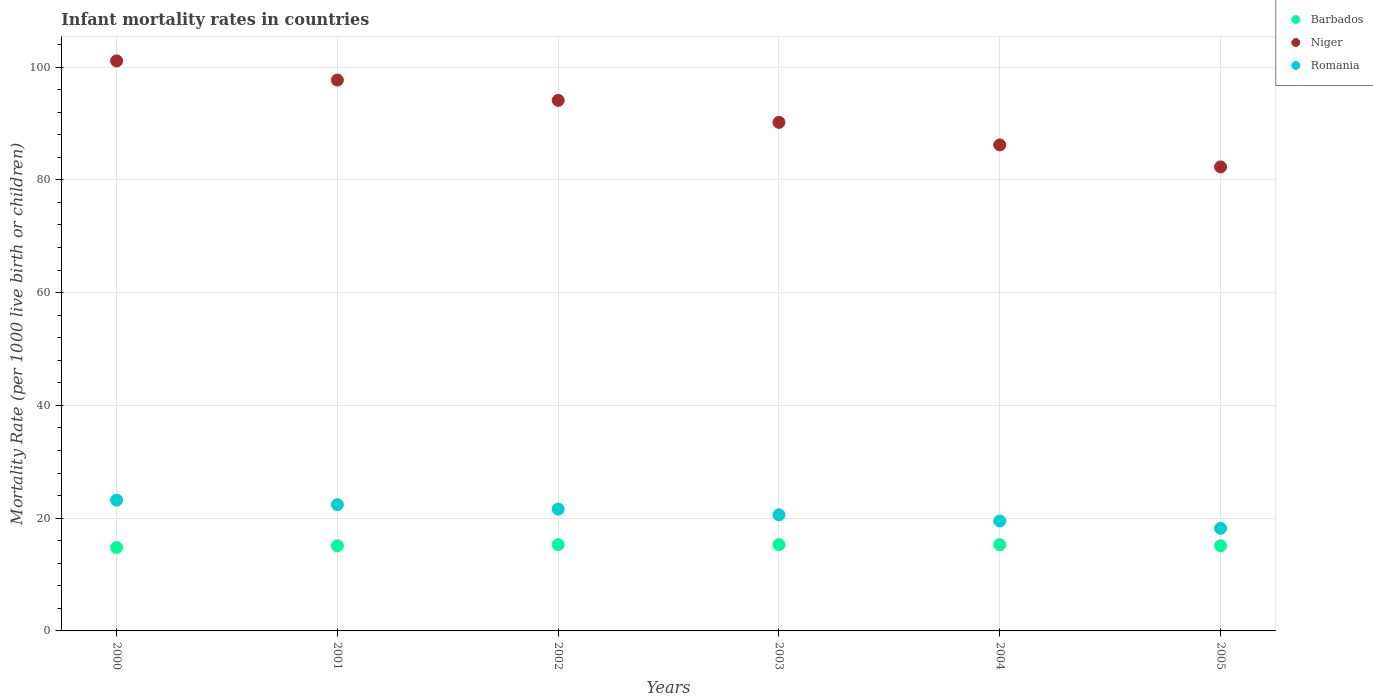What is the infant mortality rate in Niger in 2001?
Ensure brevity in your answer.  97.7. Across all years, what is the maximum infant mortality rate in Romania?
Your answer should be compact. 23.2. Across all years, what is the minimum infant mortality rate in Niger?
Offer a terse response. 82.3. In which year was the infant mortality rate in Niger minimum?
Ensure brevity in your answer.  2005. What is the total infant mortality rate in Niger in the graph?
Keep it short and to the point. 551.6. What is the difference between the infant mortality rate in Romania in 2002 and that in 2004?
Ensure brevity in your answer.  2.1. What is the difference between the infant mortality rate in Romania in 2003 and the infant mortality rate in Barbados in 2000?
Your answer should be compact. 5.8. What is the average infant mortality rate in Niger per year?
Your response must be concise. 91.93. In the year 2005, what is the difference between the infant mortality rate in Barbados and infant mortality rate in Niger?
Your answer should be compact. -67.2. In how many years, is the infant mortality rate in Niger greater than 28?
Your answer should be very brief. 6. What is the ratio of the infant mortality rate in Niger in 2004 to that in 2005?
Give a very brief answer. 1.05. Is the infant mortality rate in Barbados in 2001 less than that in 2002?
Make the answer very short. Yes. What is the difference between the highest and the second highest infant mortality rate in Niger?
Provide a short and direct response. 3.4. Is the infant mortality rate in Niger strictly less than the infant mortality rate in Barbados over the years?
Provide a succinct answer. No. How many years are there in the graph?
Provide a short and direct response. 6. Are the values on the major ticks of Y-axis written in scientific E-notation?
Provide a short and direct response. No. Does the graph contain any zero values?
Give a very brief answer. No. How are the legend labels stacked?
Your response must be concise. Vertical. What is the title of the graph?
Your answer should be very brief. Infant mortality rates in countries. Does "Turks and Caicos Islands" appear as one of the legend labels in the graph?
Your answer should be compact. No. What is the label or title of the Y-axis?
Ensure brevity in your answer.  Mortality Rate (per 1000 live birth or children). What is the Mortality Rate (per 1000 live birth or children) in Barbados in 2000?
Your answer should be very brief. 14.8. What is the Mortality Rate (per 1000 live birth or children) of Niger in 2000?
Your answer should be very brief. 101.1. What is the Mortality Rate (per 1000 live birth or children) of Romania in 2000?
Make the answer very short. 23.2. What is the Mortality Rate (per 1000 live birth or children) of Niger in 2001?
Keep it short and to the point. 97.7. What is the Mortality Rate (per 1000 live birth or children) of Romania in 2001?
Offer a very short reply. 22.4. What is the Mortality Rate (per 1000 live birth or children) of Barbados in 2002?
Give a very brief answer. 15.3. What is the Mortality Rate (per 1000 live birth or children) of Niger in 2002?
Your response must be concise. 94.1. What is the Mortality Rate (per 1000 live birth or children) in Romania in 2002?
Offer a very short reply. 21.6. What is the Mortality Rate (per 1000 live birth or children) of Niger in 2003?
Your answer should be very brief. 90.2. What is the Mortality Rate (per 1000 live birth or children) of Romania in 2003?
Your response must be concise. 20.6. What is the Mortality Rate (per 1000 live birth or children) in Niger in 2004?
Your answer should be very brief. 86.2. What is the Mortality Rate (per 1000 live birth or children) in Romania in 2004?
Offer a terse response. 19.5. What is the Mortality Rate (per 1000 live birth or children) in Barbados in 2005?
Ensure brevity in your answer.  15.1. What is the Mortality Rate (per 1000 live birth or children) in Niger in 2005?
Provide a short and direct response. 82.3. Across all years, what is the maximum Mortality Rate (per 1000 live birth or children) in Barbados?
Provide a short and direct response. 15.3. Across all years, what is the maximum Mortality Rate (per 1000 live birth or children) of Niger?
Your answer should be compact. 101.1. Across all years, what is the maximum Mortality Rate (per 1000 live birth or children) of Romania?
Keep it short and to the point. 23.2. Across all years, what is the minimum Mortality Rate (per 1000 live birth or children) in Barbados?
Your answer should be compact. 14.8. Across all years, what is the minimum Mortality Rate (per 1000 live birth or children) of Niger?
Your answer should be compact. 82.3. Across all years, what is the minimum Mortality Rate (per 1000 live birth or children) in Romania?
Make the answer very short. 18.2. What is the total Mortality Rate (per 1000 live birth or children) in Barbados in the graph?
Your answer should be very brief. 90.9. What is the total Mortality Rate (per 1000 live birth or children) of Niger in the graph?
Your answer should be very brief. 551.6. What is the total Mortality Rate (per 1000 live birth or children) in Romania in the graph?
Provide a succinct answer. 125.5. What is the difference between the Mortality Rate (per 1000 live birth or children) of Barbados in 2000 and that in 2001?
Ensure brevity in your answer.  -0.3. What is the difference between the Mortality Rate (per 1000 live birth or children) in Niger in 2000 and that in 2001?
Your response must be concise. 3.4. What is the difference between the Mortality Rate (per 1000 live birth or children) in Barbados in 2000 and that in 2004?
Provide a short and direct response. -0.5. What is the difference between the Mortality Rate (per 1000 live birth or children) in Niger in 2000 and that in 2004?
Provide a short and direct response. 14.9. What is the difference between the Mortality Rate (per 1000 live birth or children) of Romania in 2000 and that in 2004?
Keep it short and to the point. 3.7. What is the difference between the Mortality Rate (per 1000 live birth or children) in Barbados in 2000 and that in 2005?
Provide a short and direct response. -0.3. What is the difference between the Mortality Rate (per 1000 live birth or children) of Romania in 2000 and that in 2005?
Provide a succinct answer. 5. What is the difference between the Mortality Rate (per 1000 live birth or children) in Barbados in 2001 and that in 2002?
Provide a succinct answer. -0.2. What is the difference between the Mortality Rate (per 1000 live birth or children) of Niger in 2001 and that in 2002?
Ensure brevity in your answer.  3.6. What is the difference between the Mortality Rate (per 1000 live birth or children) in Romania in 2001 and that in 2002?
Make the answer very short. 0.8. What is the difference between the Mortality Rate (per 1000 live birth or children) in Romania in 2001 and that in 2003?
Provide a short and direct response. 1.8. What is the difference between the Mortality Rate (per 1000 live birth or children) in Romania in 2001 and that in 2004?
Offer a terse response. 2.9. What is the difference between the Mortality Rate (per 1000 live birth or children) of Barbados in 2001 and that in 2005?
Offer a terse response. 0. What is the difference between the Mortality Rate (per 1000 live birth or children) of Niger in 2002 and that in 2003?
Provide a succinct answer. 3.9. What is the difference between the Mortality Rate (per 1000 live birth or children) of Barbados in 2002 and that in 2004?
Your answer should be very brief. 0. What is the difference between the Mortality Rate (per 1000 live birth or children) of Romania in 2002 and that in 2004?
Your answer should be compact. 2.1. What is the difference between the Mortality Rate (per 1000 live birth or children) of Barbados in 2002 and that in 2005?
Your answer should be very brief. 0.2. What is the difference between the Mortality Rate (per 1000 live birth or children) of Niger in 2002 and that in 2005?
Keep it short and to the point. 11.8. What is the difference between the Mortality Rate (per 1000 live birth or children) of Romania in 2002 and that in 2005?
Provide a succinct answer. 3.4. What is the difference between the Mortality Rate (per 1000 live birth or children) in Barbados in 2003 and that in 2004?
Provide a succinct answer. 0. What is the difference between the Mortality Rate (per 1000 live birth or children) of Niger in 2003 and that in 2004?
Give a very brief answer. 4. What is the difference between the Mortality Rate (per 1000 live birth or children) of Romania in 2003 and that in 2004?
Give a very brief answer. 1.1. What is the difference between the Mortality Rate (per 1000 live birth or children) in Niger in 2003 and that in 2005?
Provide a short and direct response. 7.9. What is the difference between the Mortality Rate (per 1000 live birth or children) of Barbados in 2004 and that in 2005?
Give a very brief answer. 0.2. What is the difference between the Mortality Rate (per 1000 live birth or children) in Niger in 2004 and that in 2005?
Your answer should be compact. 3.9. What is the difference between the Mortality Rate (per 1000 live birth or children) of Barbados in 2000 and the Mortality Rate (per 1000 live birth or children) of Niger in 2001?
Offer a very short reply. -82.9. What is the difference between the Mortality Rate (per 1000 live birth or children) of Niger in 2000 and the Mortality Rate (per 1000 live birth or children) of Romania in 2001?
Your answer should be very brief. 78.7. What is the difference between the Mortality Rate (per 1000 live birth or children) of Barbados in 2000 and the Mortality Rate (per 1000 live birth or children) of Niger in 2002?
Provide a succinct answer. -79.3. What is the difference between the Mortality Rate (per 1000 live birth or children) in Barbados in 2000 and the Mortality Rate (per 1000 live birth or children) in Romania in 2002?
Keep it short and to the point. -6.8. What is the difference between the Mortality Rate (per 1000 live birth or children) of Niger in 2000 and the Mortality Rate (per 1000 live birth or children) of Romania in 2002?
Offer a terse response. 79.5. What is the difference between the Mortality Rate (per 1000 live birth or children) in Barbados in 2000 and the Mortality Rate (per 1000 live birth or children) in Niger in 2003?
Ensure brevity in your answer.  -75.4. What is the difference between the Mortality Rate (per 1000 live birth or children) of Barbados in 2000 and the Mortality Rate (per 1000 live birth or children) of Romania in 2003?
Give a very brief answer. -5.8. What is the difference between the Mortality Rate (per 1000 live birth or children) of Niger in 2000 and the Mortality Rate (per 1000 live birth or children) of Romania in 2003?
Offer a terse response. 80.5. What is the difference between the Mortality Rate (per 1000 live birth or children) in Barbados in 2000 and the Mortality Rate (per 1000 live birth or children) in Niger in 2004?
Keep it short and to the point. -71.4. What is the difference between the Mortality Rate (per 1000 live birth or children) in Barbados in 2000 and the Mortality Rate (per 1000 live birth or children) in Romania in 2004?
Ensure brevity in your answer.  -4.7. What is the difference between the Mortality Rate (per 1000 live birth or children) of Niger in 2000 and the Mortality Rate (per 1000 live birth or children) of Romania in 2004?
Provide a short and direct response. 81.6. What is the difference between the Mortality Rate (per 1000 live birth or children) of Barbados in 2000 and the Mortality Rate (per 1000 live birth or children) of Niger in 2005?
Give a very brief answer. -67.5. What is the difference between the Mortality Rate (per 1000 live birth or children) of Barbados in 2000 and the Mortality Rate (per 1000 live birth or children) of Romania in 2005?
Offer a terse response. -3.4. What is the difference between the Mortality Rate (per 1000 live birth or children) in Niger in 2000 and the Mortality Rate (per 1000 live birth or children) in Romania in 2005?
Make the answer very short. 82.9. What is the difference between the Mortality Rate (per 1000 live birth or children) of Barbados in 2001 and the Mortality Rate (per 1000 live birth or children) of Niger in 2002?
Make the answer very short. -79. What is the difference between the Mortality Rate (per 1000 live birth or children) of Niger in 2001 and the Mortality Rate (per 1000 live birth or children) of Romania in 2002?
Your answer should be very brief. 76.1. What is the difference between the Mortality Rate (per 1000 live birth or children) in Barbados in 2001 and the Mortality Rate (per 1000 live birth or children) in Niger in 2003?
Your response must be concise. -75.1. What is the difference between the Mortality Rate (per 1000 live birth or children) in Niger in 2001 and the Mortality Rate (per 1000 live birth or children) in Romania in 2003?
Offer a terse response. 77.1. What is the difference between the Mortality Rate (per 1000 live birth or children) in Barbados in 2001 and the Mortality Rate (per 1000 live birth or children) in Niger in 2004?
Keep it short and to the point. -71.1. What is the difference between the Mortality Rate (per 1000 live birth or children) in Barbados in 2001 and the Mortality Rate (per 1000 live birth or children) in Romania in 2004?
Offer a very short reply. -4.4. What is the difference between the Mortality Rate (per 1000 live birth or children) in Niger in 2001 and the Mortality Rate (per 1000 live birth or children) in Romania in 2004?
Offer a very short reply. 78.2. What is the difference between the Mortality Rate (per 1000 live birth or children) in Barbados in 2001 and the Mortality Rate (per 1000 live birth or children) in Niger in 2005?
Make the answer very short. -67.2. What is the difference between the Mortality Rate (per 1000 live birth or children) of Barbados in 2001 and the Mortality Rate (per 1000 live birth or children) of Romania in 2005?
Give a very brief answer. -3.1. What is the difference between the Mortality Rate (per 1000 live birth or children) in Niger in 2001 and the Mortality Rate (per 1000 live birth or children) in Romania in 2005?
Keep it short and to the point. 79.5. What is the difference between the Mortality Rate (per 1000 live birth or children) in Barbados in 2002 and the Mortality Rate (per 1000 live birth or children) in Niger in 2003?
Give a very brief answer. -74.9. What is the difference between the Mortality Rate (per 1000 live birth or children) of Niger in 2002 and the Mortality Rate (per 1000 live birth or children) of Romania in 2003?
Provide a succinct answer. 73.5. What is the difference between the Mortality Rate (per 1000 live birth or children) in Barbados in 2002 and the Mortality Rate (per 1000 live birth or children) in Niger in 2004?
Make the answer very short. -70.9. What is the difference between the Mortality Rate (per 1000 live birth or children) of Niger in 2002 and the Mortality Rate (per 1000 live birth or children) of Romania in 2004?
Your answer should be compact. 74.6. What is the difference between the Mortality Rate (per 1000 live birth or children) in Barbados in 2002 and the Mortality Rate (per 1000 live birth or children) in Niger in 2005?
Keep it short and to the point. -67. What is the difference between the Mortality Rate (per 1000 live birth or children) of Niger in 2002 and the Mortality Rate (per 1000 live birth or children) of Romania in 2005?
Your response must be concise. 75.9. What is the difference between the Mortality Rate (per 1000 live birth or children) of Barbados in 2003 and the Mortality Rate (per 1000 live birth or children) of Niger in 2004?
Give a very brief answer. -70.9. What is the difference between the Mortality Rate (per 1000 live birth or children) of Niger in 2003 and the Mortality Rate (per 1000 live birth or children) of Romania in 2004?
Offer a terse response. 70.7. What is the difference between the Mortality Rate (per 1000 live birth or children) in Barbados in 2003 and the Mortality Rate (per 1000 live birth or children) in Niger in 2005?
Make the answer very short. -67. What is the difference between the Mortality Rate (per 1000 live birth or children) of Barbados in 2003 and the Mortality Rate (per 1000 live birth or children) of Romania in 2005?
Provide a succinct answer. -2.9. What is the difference between the Mortality Rate (per 1000 live birth or children) of Barbados in 2004 and the Mortality Rate (per 1000 live birth or children) of Niger in 2005?
Provide a succinct answer. -67. What is the difference between the Mortality Rate (per 1000 live birth or children) in Barbados in 2004 and the Mortality Rate (per 1000 live birth or children) in Romania in 2005?
Your answer should be very brief. -2.9. What is the difference between the Mortality Rate (per 1000 live birth or children) in Niger in 2004 and the Mortality Rate (per 1000 live birth or children) in Romania in 2005?
Provide a short and direct response. 68. What is the average Mortality Rate (per 1000 live birth or children) of Barbados per year?
Make the answer very short. 15.15. What is the average Mortality Rate (per 1000 live birth or children) of Niger per year?
Your response must be concise. 91.93. What is the average Mortality Rate (per 1000 live birth or children) in Romania per year?
Your response must be concise. 20.92. In the year 2000, what is the difference between the Mortality Rate (per 1000 live birth or children) in Barbados and Mortality Rate (per 1000 live birth or children) in Niger?
Offer a terse response. -86.3. In the year 2000, what is the difference between the Mortality Rate (per 1000 live birth or children) of Barbados and Mortality Rate (per 1000 live birth or children) of Romania?
Give a very brief answer. -8.4. In the year 2000, what is the difference between the Mortality Rate (per 1000 live birth or children) in Niger and Mortality Rate (per 1000 live birth or children) in Romania?
Provide a succinct answer. 77.9. In the year 2001, what is the difference between the Mortality Rate (per 1000 live birth or children) in Barbados and Mortality Rate (per 1000 live birth or children) in Niger?
Give a very brief answer. -82.6. In the year 2001, what is the difference between the Mortality Rate (per 1000 live birth or children) of Niger and Mortality Rate (per 1000 live birth or children) of Romania?
Make the answer very short. 75.3. In the year 2002, what is the difference between the Mortality Rate (per 1000 live birth or children) of Barbados and Mortality Rate (per 1000 live birth or children) of Niger?
Your answer should be very brief. -78.8. In the year 2002, what is the difference between the Mortality Rate (per 1000 live birth or children) of Niger and Mortality Rate (per 1000 live birth or children) of Romania?
Provide a short and direct response. 72.5. In the year 2003, what is the difference between the Mortality Rate (per 1000 live birth or children) of Barbados and Mortality Rate (per 1000 live birth or children) of Niger?
Offer a terse response. -74.9. In the year 2003, what is the difference between the Mortality Rate (per 1000 live birth or children) in Barbados and Mortality Rate (per 1000 live birth or children) in Romania?
Keep it short and to the point. -5.3. In the year 2003, what is the difference between the Mortality Rate (per 1000 live birth or children) in Niger and Mortality Rate (per 1000 live birth or children) in Romania?
Your answer should be compact. 69.6. In the year 2004, what is the difference between the Mortality Rate (per 1000 live birth or children) in Barbados and Mortality Rate (per 1000 live birth or children) in Niger?
Provide a short and direct response. -70.9. In the year 2004, what is the difference between the Mortality Rate (per 1000 live birth or children) in Niger and Mortality Rate (per 1000 live birth or children) in Romania?
Offer a terse response. 66.7. In the year 2005, what is the difference between the Mortality Rate (per 1000 live birth or children) of Barbados and Mortality Rate (per 1000 live birth or children) of Niger?
Offer a very short reply. -67.2. In the year 2005, what is the difference between the Mortality Rate (per 1000 live birth or children) in Barbados and Mortality Rate (per 1000 live birth or children) in Romania?
Provide a succinct answer. -3.1. In the year 2005, what is the difference between the Mortality Rate (per 1000 live birth or children) in Niger and Mortality Rate (per 1000 live birth or children) in Romania?
Your response must be concise. 64.1. What is the ratio of the Mortality Rate (per 1000 live birth or children) in Barbados in 2000 to that in 2001?
Make the answer very short. 0.98. What is the ratio of the Mortality Rate (per 1000 live birth or children) of Niger in 2000 to that in 2001?
Your answer should be compact. 1.03. What is the ratio of the Mortality Rate (per 1000 live birth or children) in Romania in 2000 to that in 2001?
Your response must be concise. 1.04. What is the ratio of the Mortality Rate (per 1000 live birth or children) in Barbados in 2000 to that in 2002?
Your response must be concise. 0.97. What is the ratio of the Mortality Rate (per 1000 live birth or children) in Niger in 2000 to that in 2002?
Provide a short and direct response. 1.07. What is the ratio of the Mortality Rate (per 1000 live birth or children) of Romania in 2000 to that in 2002?
Offer a terse response. 1.07. What is the ratio of the Mortality Rate (per 1000 live birth or children) of Barbados in 2000 to that in 2003?
Give a very brief answer. 0.97. What is the ratio of the Mortality Rate (per 1000 live birth or children) in Niger in 2000 to that in 2003?
Make the answer very short. 1.12. What is the ratio of the Mortality Rate (per 1000 live birth or children) in Romania in 2000 to that in 2003?
Ensure brevity in your answer.  1.13. What is the ratio of the Mortality Rate (per 1000 live birth or children) of Barbados in 2000 to that in 2004?
Offer a terse response. 0.97. What is the ratio of the Mortality Rate (per 1000 live birth or children) of Niger in 2000 to that in 2004?
Offer a very short reply. 1.17. What is the ratio of the Mortality Rate (per 1000 live birth or children) of Romania in 2000 to that in 2004?
Ensure brevity in your answer.  1.19. What is the ratio of the Mortality Rate (per 1000 live birth or children) in Barbados in 2000 to that in 2005?
Offer a very short reply. 0.98. What is the ratio of the Mortality Rate (per 1000 live birth or children) of Niger in 2000 to that in 2005?
Provide a succinct answer. 1.23. What is the ratio of the Mortality Rate (per 1000 live birth or children) of Romania in 2000 to that in 2005?
Provide a short and direct response. 1.27. What is the ratio of the Mortality Rate (per 1000 live birth or children) of Barbados in 2001 to that in 2002?
Your answer should be compact. 0.99. What is the ratio of the Mortality Rate (per 1000 live birth or children) of Niger in 2001 to that in 2002?
Provide a succinct answer. 1.04. What is the ratio of the Mortality Rate (per 1000 live birth or children) in Barbados in 2001 to that in 2003?
Your answer should be compact. 0.99. What is the ratio of the Mortality Rate (per 1000 live birth or children) in Niger in 2001 to that in 2003?
Make the answer very short. 1.08. What is the ratio of the Mortality Rate (per 1000 live birth or children) of Romania in 2001 to that in 2003?
Offer a very short reply. 1.09. What is the ratio of the Mortality Rate (per 1000 live birth or children) in Barbados in 2001 to that in 2004?
Your answer should be compact. 0.99. What is the ratio of the Mortality Rate (per 1000 live birth or children) of Niger in 2001 to that in 2004?
Ensure brevity in your answer.  1.13. What is the ratio of the Mortality Rate (per 1000 live birth or children) of Romania in 2001 to that in 2004?
Your answer should be very brief. 1.15. What is the ratio of the Mortality Rate (per 1000 live birth or children) in Barbados in 2001 to that in 2005?
Offer a very short reply. 1. What is the ratio of the Mortality Rate (per 1000 live birth or children) of Niger in 2001 to that in 2005?
Give a very brief answer. 1.19. What is the ratio of the Mortality Rate (per 1000 live birth or children) of Romania in 2001 to that in 2005?
Make the answer very short. 1.23. What is the ratio of the Mortality Rate (per 1000 live birth or children) in Niger in 2002 to that in 2003?
Keep it short and to the point. 1.04. What is the ratio of the Mortality Rate (per 1000 live birth or children) in Romania in 2002 to that in 2003?
Your answer should be very brief. 1.05. What is the ratio of the Mortality Rate (per 1000 live birth or children) of Niger in 2002 to that in 2004?
Offer a very short reply. 1.09. What is the ratio of the Mortality Rate (per 1000 live birth or children) of Romania in 2002 to that in 2004?
Make the answer very short. 1.11. What is the ratio of the Mortality Rate (per 1000 live birth or children) of Barbados in 2002 to that in 2005?
Ensure brevity in your answer.  1.01. What is the ratio of the Mortality Rate (per 1000 live birth or children) in Niger in 2002 to that in 2005?
Your response must be concise. 1.14. What is the ratio of the Mortality Rate (per 1000 live birth or children) of Romania in 2002 to that in 2005?
Ensure brevity in your answer.  1.19. What is the ratio of the Mortality Rate (per 1000 live birth or children) of Niger in 2003 to that in 2004?
Give a very brief answer. 1.05. What is the ratio of the Mortality Rate (per 1000 live birth or children) of Romania in 2003 to that in 2004?
Ensure brevity in your answer.  1.06. What is the ratio of the Mortality Rate (per 1000 live birth or children) in Barbados in 2003 to that in 2005?
Provide a short and direct response. 1.01. What is the ratio of the Mortality Rate (per 1000 live birth or children) in Niger in 2003 to that in 2005?
Give a very brief answer. 1.1. What is the ratio of the Mortality Rate (per 1000 live birth or children) of Romania in 2003 to that in 2005?
Provide a short and direct response. 1.13. What is the ratio of the Mortality Rate (per 1000 live birth or children) of Barbados in 2004 to that in 2005?
Ensure brevity in your answer.  1.01. What is the ratio of the Mortality Rate (per 1000 live birth or children) in Niger in 2004 to that in 2005?
Offer a very short reply. 1.05. What is the ratio of the Mortality Rate (per 1000 live birth or children) of Romania in 2004 to that in 2005?
Your answer should be compact. 1.07. What is the difference between the highest and the second highest Mortality Rate (per 1000 live birth or children) of Niger?
Provide a short and direct response. 3.4. What is the difference between the highest and the second highest Mortality Rate (per 1000 live birth or children) of Romania?
Provide a succinct answer. 0.8. What is the difference between the highest and the lowest Mortality Rate (per 1000 live birth or children) in Romania?
Offer a very short reply. 5. 